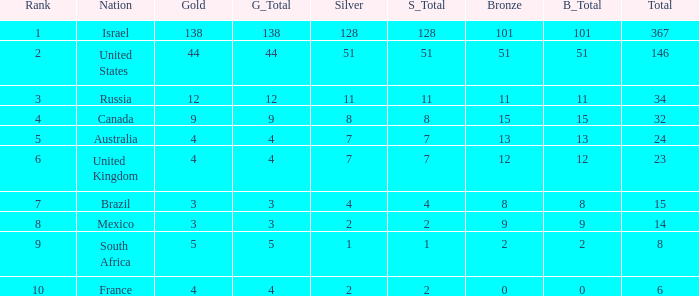Can you parse all the data within this table? {'header': ['Rank', 'Nation', 'Gold', 'G_Total', 'Silver', 'S_Total', 'Bronze', 'B_Total', 'Total'], 'rows': [['1', 'Israel', '138', '138', '128', '128', '101', '101', '367'], ['2', 'United States', '44', '44', '51', '51', '51', '51', '146'], ['3', 'Russia', '12', '12', '11', '11', '11', '11', '34'], ['4', 'Canada', '9', '9', '8', '8', '15', '15', '32'], ['5', 'Australia', '4', '4', '7', '7', '13', '13', '24'], ['6', 'United Kingdom', '4', '4', '7', '7', '12', '12', '23'], ['7', 'Brazil', '3', '3', '4', '4', '8', '8', '15'], ['8', 'Mexico', '3', '3', '2', '2', '9', '9', '14'], ['9', 'South Africa', '5', '5', '1', '1', '2', '2', '8'], ['10', 'France', '4', '4', '2', '2', '0', '0', '6']]} What is the gold medal count for the country with a total greater than 32 and more than 128 silvers? None. 